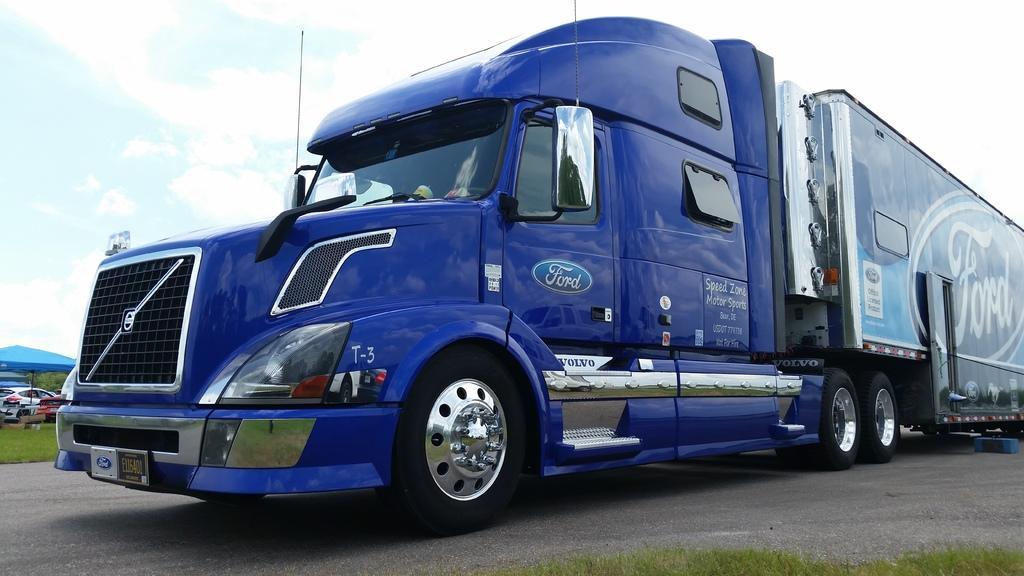Please provide a concise description of this image. There is a vehicle on the road. Here we can see grass, cars, and an umbrella. In the background there is sky with clouds. 